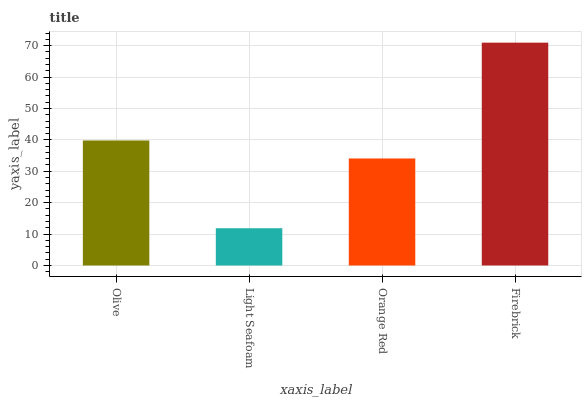Is Light Seafoam the minimum?
Answer yes or no. Yes. Is Firebrick the maximum?
Answer yes or no. Yes. Is Orange Red the minimum?
Answer yes or no. No. Is Orange Red the maximum?
Answer yes or no. No. Is Orange Red greater than Light Seafoam?
Answer yes or no. Yes. Is Light Seafoam less than Orange Red?
Answer yes or no. Yes. Is Light Seafoam greater than Orange Red?
Answer yes or no. No. Is Orange Red less than Light Seafoam?
Answer yes or no. No. Is Olive the high median?
Answer yes or no. Yes. Is Orange Red the low median?
Answer yes or no. Yes. Is Light Seafoam the high median?
Answer yes or no. No. Is Light Seafoam the low median?
Answer yes or no. No. 